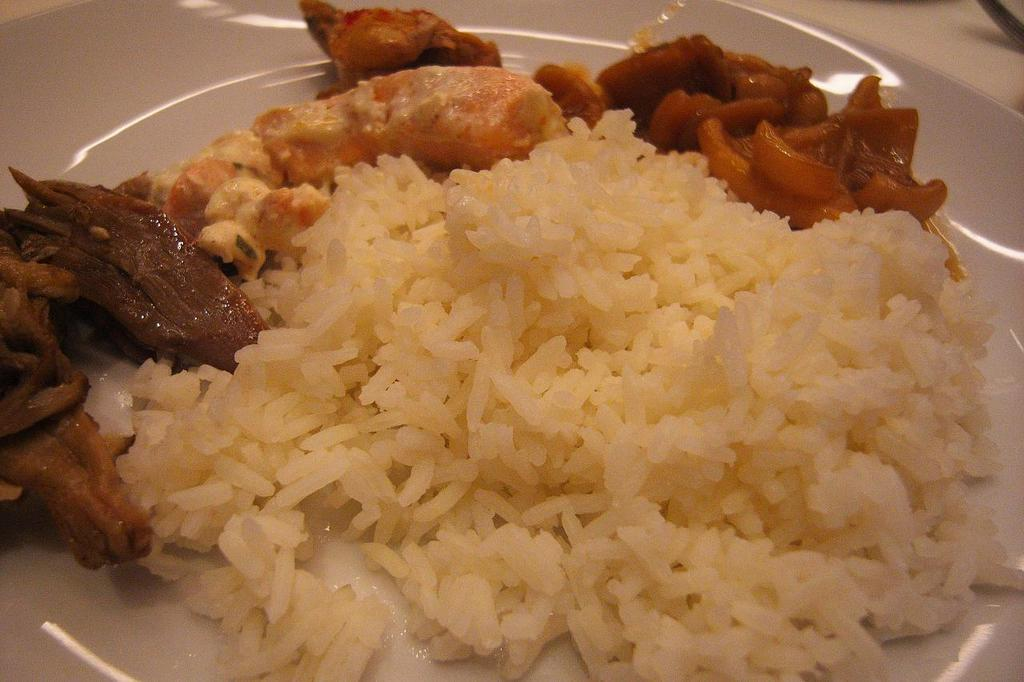What object is incomplete or missing a part in the image? There is a truncated plate in the image. Where is the plate located? The plate is on a surface. What is on the plate? There is food in the plate. What type of throne is depicted in the image? There is no throne present in the image. 